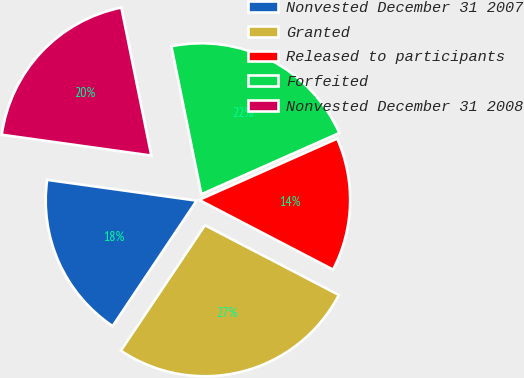<chart> <loc_0><loc_0><loc_500><loc_500><pie_chart><fcel>Nonvested December 31 2007<fcel>Granted<fcel>Released to participants<fcel>Forfeited<fcel>Nonvested December 31 2008<nl><fcel>17.8%<fcel>26.76%<fcel>14.29%<fcel>21.53%<fcel>19.62%<nl></chart> 